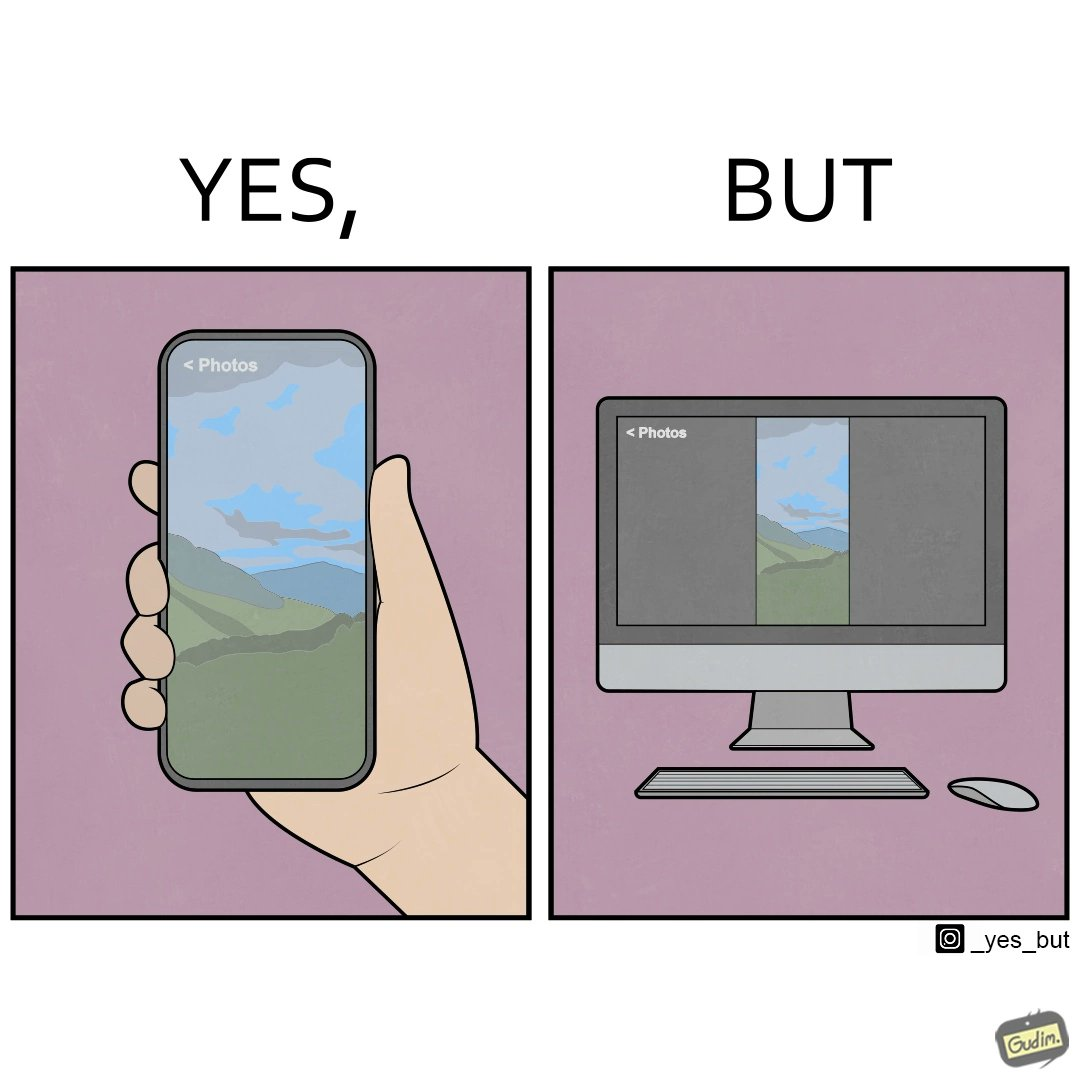Describe what you see in the left and right parts of this image. In the left part of the image: an image of a scenic view on mobile In the right part of the image: an image of a scenic view in portrait mode on a computer monitor. 